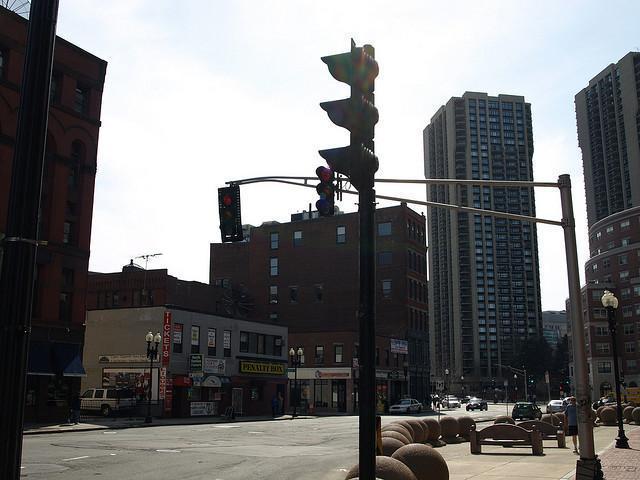How many giraffes are there?
Give a very brief answer. 0. 